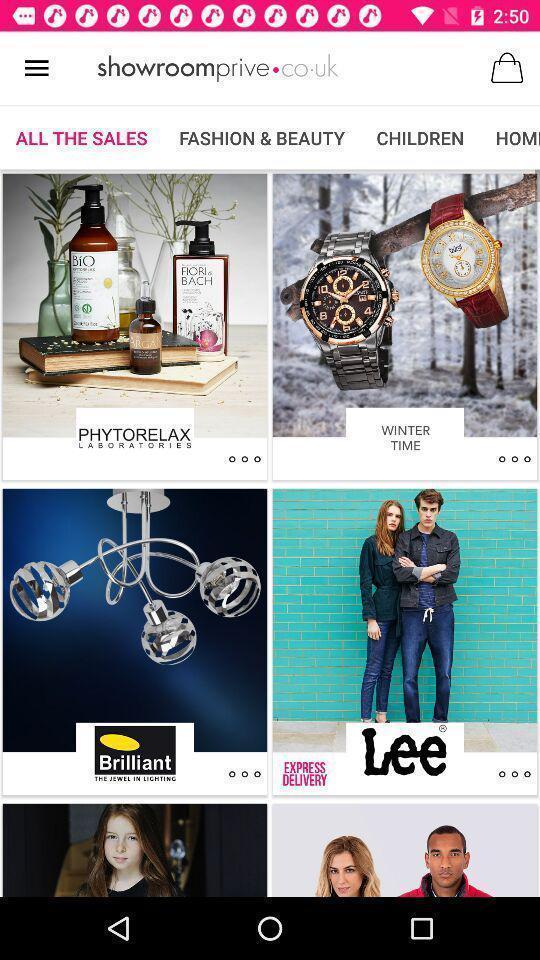Explain the elements present in this screenshot. Screen page displaying various categories in the shopping app. 